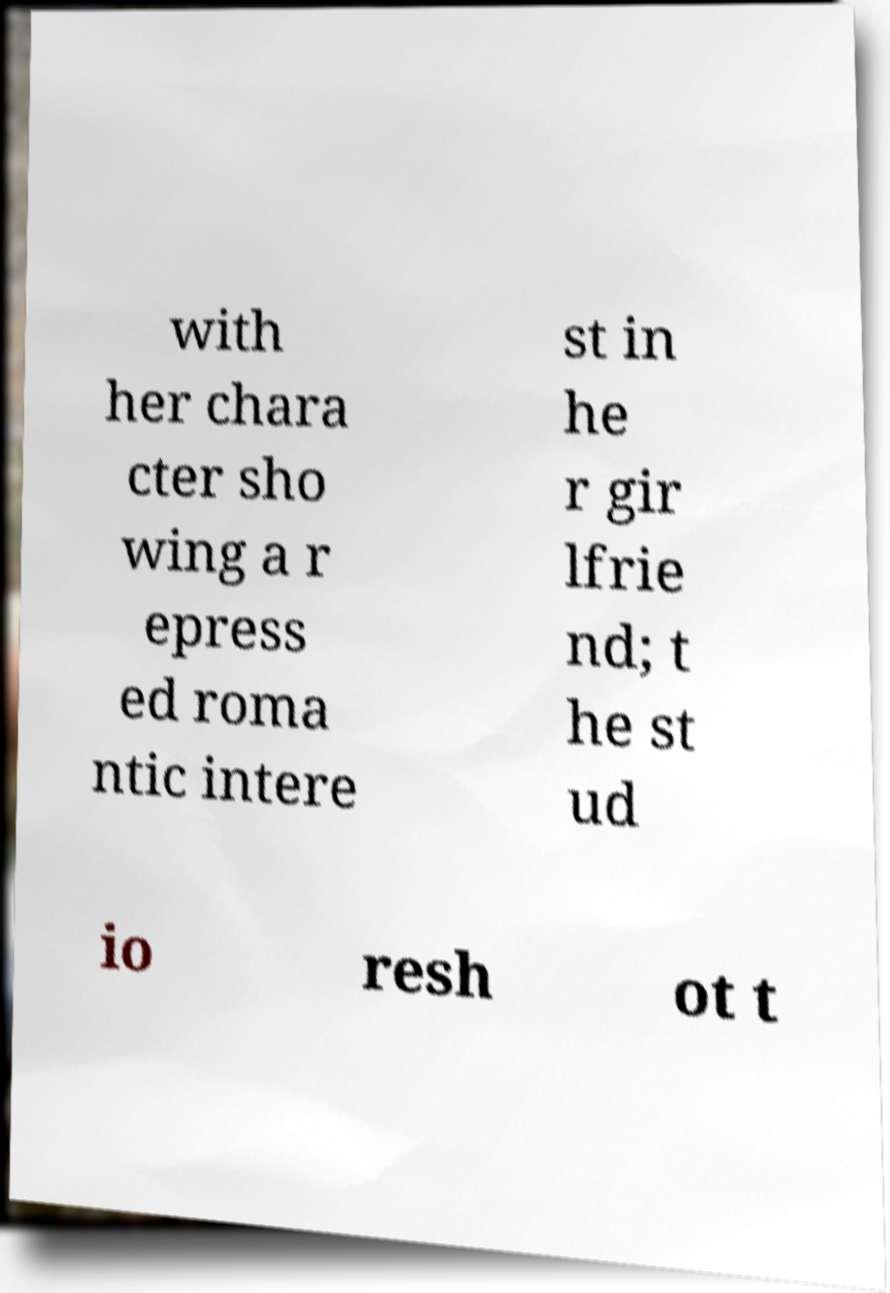Could you assist in decoding the text presented in this image and type it out clearly? with her chara cter sho wing a r epress ed roma ntic intere st in he r gir lfrie nd; t he st ud io resh ot t 